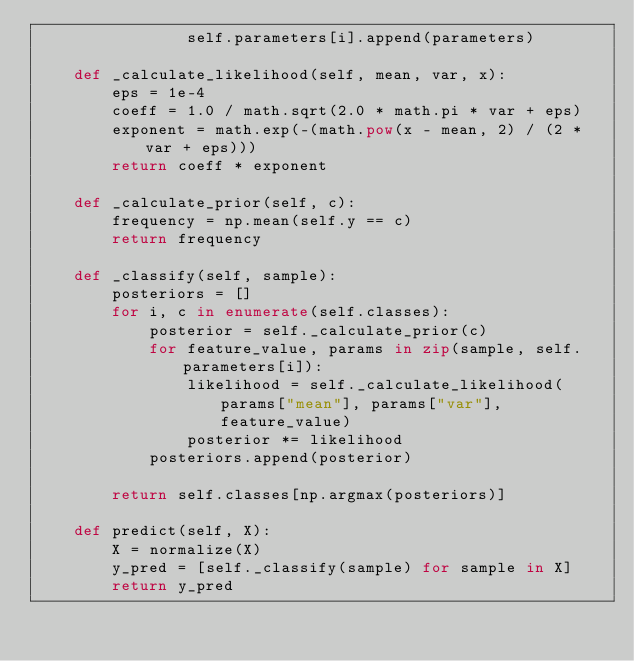Convert code to text. <code><loc_0><loc_0><loc_500><loc_500><_Python_>                self.parameters[i].append(parameters)

    def _calculate_likelihood(self, mean, var, x):
        eps = 1e-4
        coeff = 1.0 / math.sqrt(2.0 * math.pi * var + eps)
        exponent = math.exp(-(math.pow(x - mean, 2) / (2 * var + eps)))
        return coeff * exponent

    def _calculate_prior(self, c):
        frequency = np.mean(self.y == c)
        return frequency

    def _classify(self, sample):
        posteriors = []
        for i, c in enumerate(self.classes):
            posterior = self._calculate_prior(c)
            for feature_value, params in zip(sample, self.parameters[i]):
                likelihood = self._calculate_likelihood(params["mean"], params["var"], feature_value)
                posterior *= likelihood
            posteriors.append(posterior)
        
        return self.classes[np.argmax(posteriors)]

    def predict(self, X):
        X = normalize(X)
        y_pred = [self._classify(sample) for sample in X]
        return y_pred</code> 